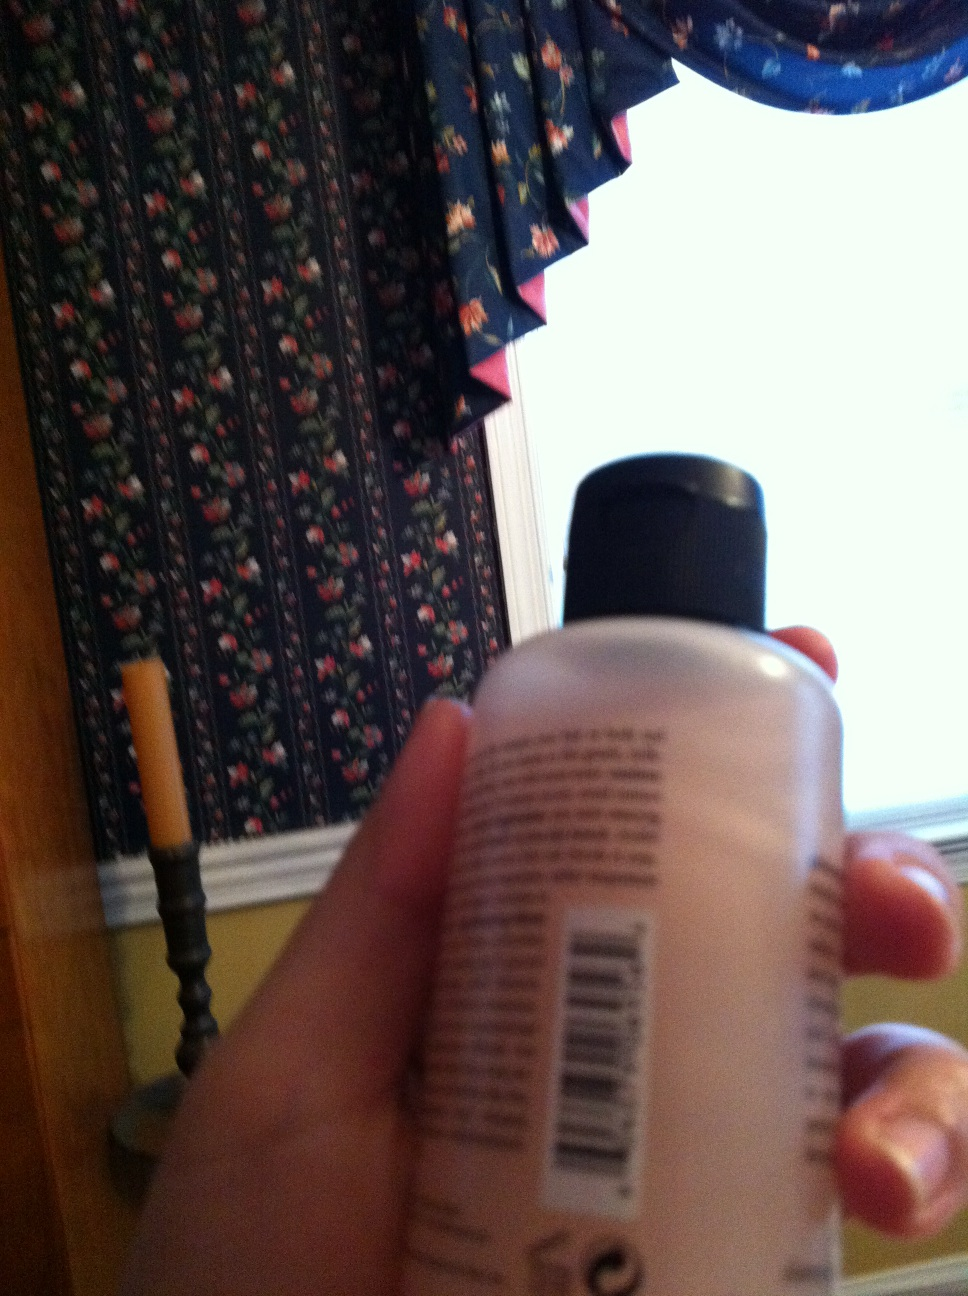Can you describe the environment where this photo was taken? It appears that this photo was taken in a home, likely in a kitchen or dining area. The background shows a decorative wallpaper with a floral pattern, a window with dark-colored curtains, and a candle on a stand. The overall ambiance suggests a cozy, well-decorated indoor setting. 